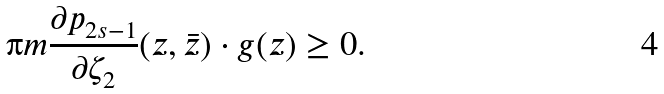Convert formula to latex. <formula><loc_0><loc_0><loc_500><loc_500>\i m \frac { \partial p _ { 2 s - 1 } } { \partial \zeta _ { 2 } } ( z , \bar { z } ) \cdot g ( z ) \geq 0 .</formula> 